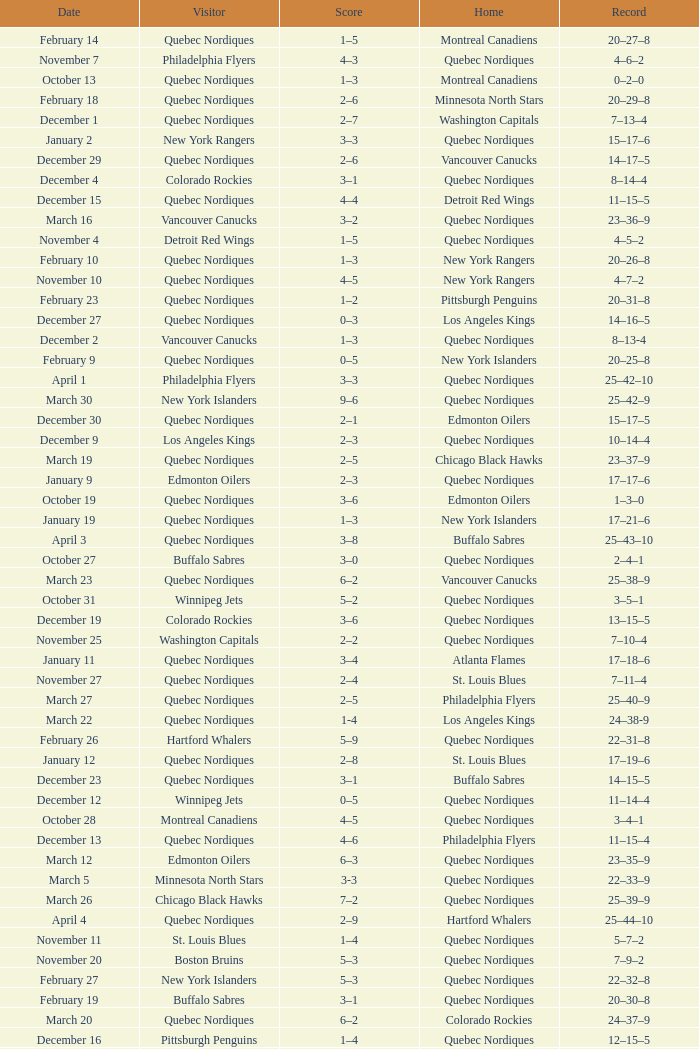Which Home has a Record of 16–17–6? Toronto Maple Leafs. 